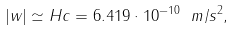Convert formula to latex. <formula><loc_0><loc_0><loc_500><loc_500>| w | \simeq H c = 6 . 4 1 9 \cdot 1 0 ^ { - 1 0 } \ m / s ^ { 2 } ,</formula> 